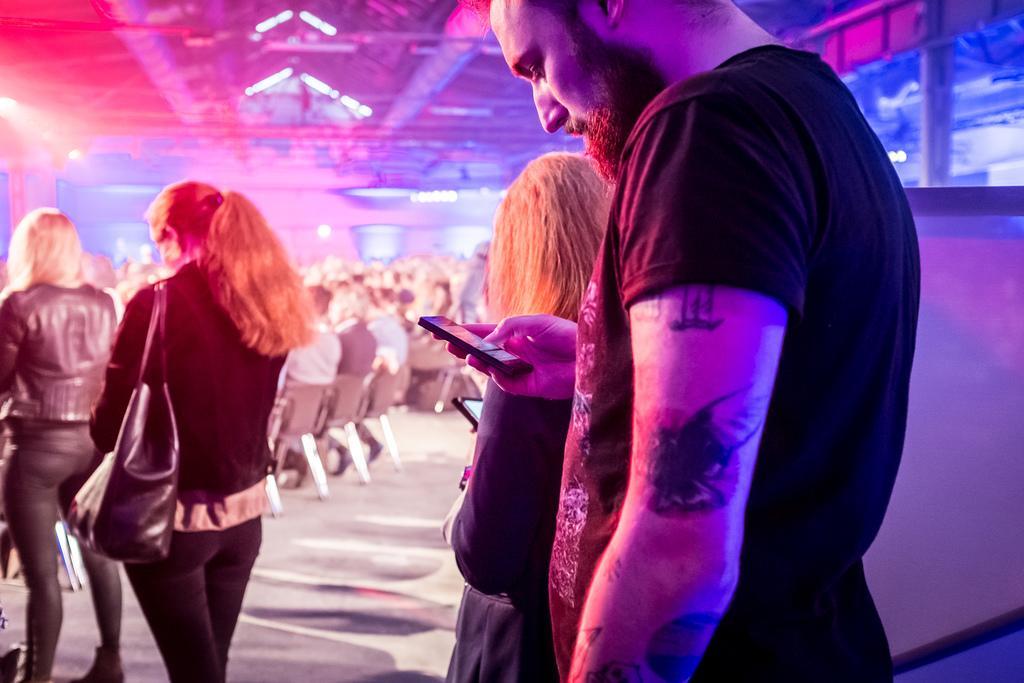In one or two sentences, can you explain what this image depicts? In this picture I can see there is a man standing and holding a smart phone and there are few women walking and they are wearing hand bag and few people sitting in the chairs and there are lights attached to ceiling. 